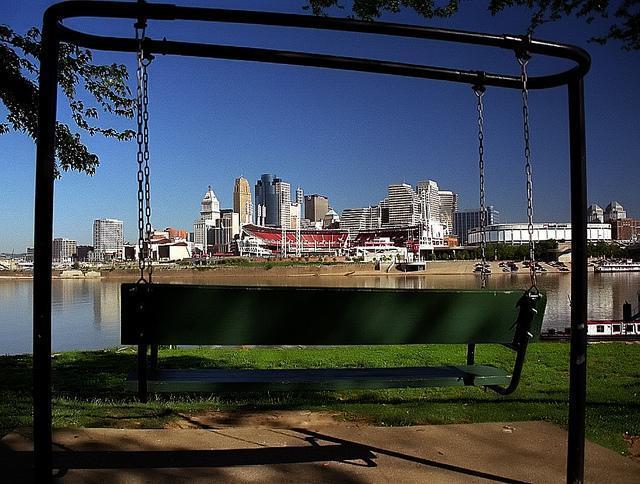How many people are on the swing?
Give a very brief answer. 0. How many blue box by the red couch and located on the left of the coffee table ?
Give a very brief answer. 0. 